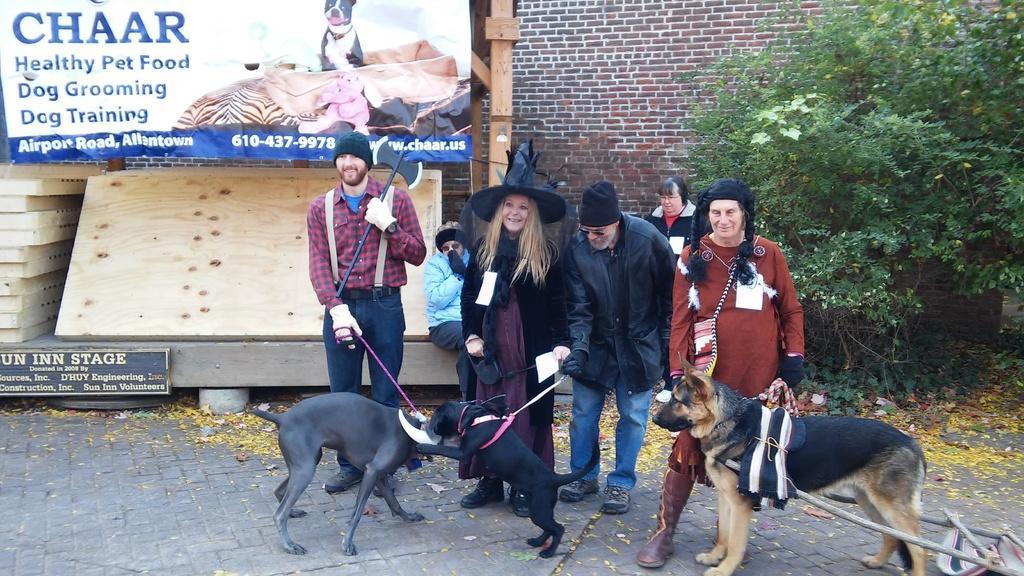Please provide a concise description of this image. This picture describes about group of people, few people wore costumes, in front of them we can find dogs, in the background we can see a hoarding, few trees and wooden planks. 